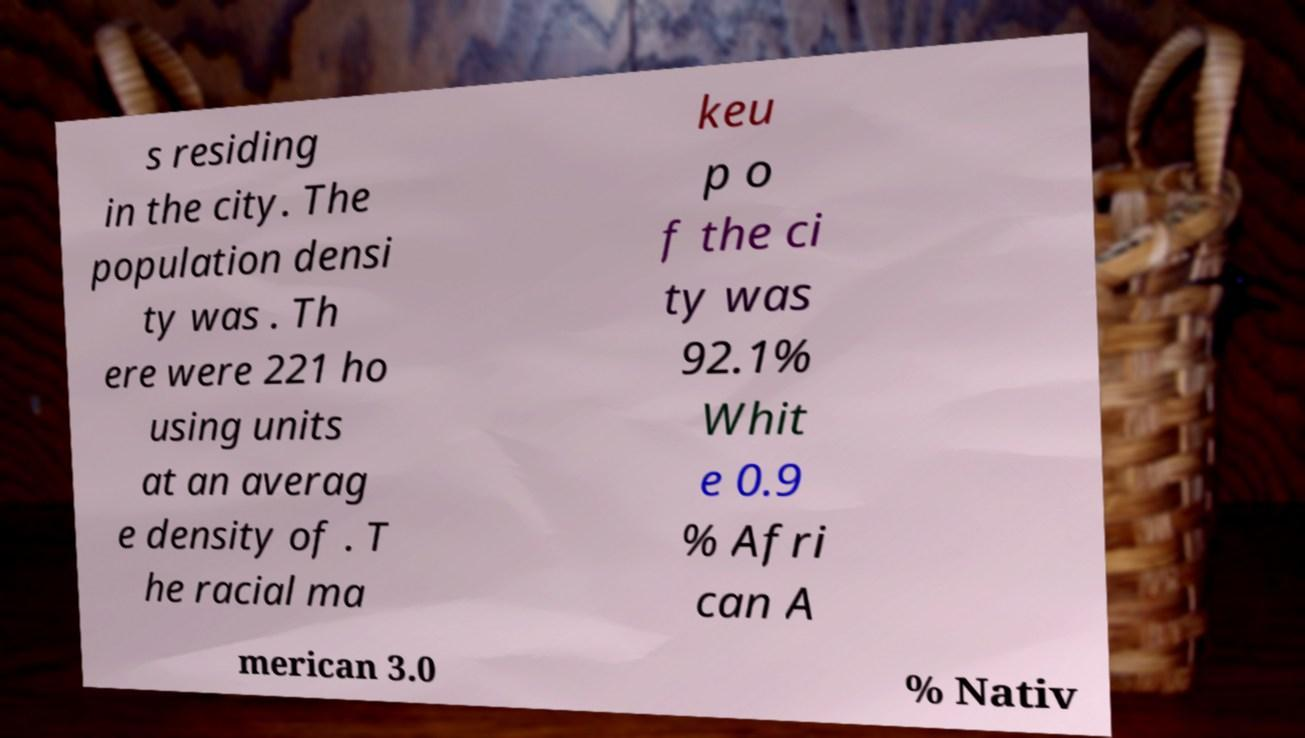Can you read and provide the text displayed in the image?This photo seems to have some interesting text. Can you extract and type it out for me? s residing in the city. The population densi ty was . Th ere were 221 ho using units at an averag e density of . T he racial ma keu p o f the ci ty was 92.1% Whit e 0.9 % Afri can A merican 3.0 % Nativ 